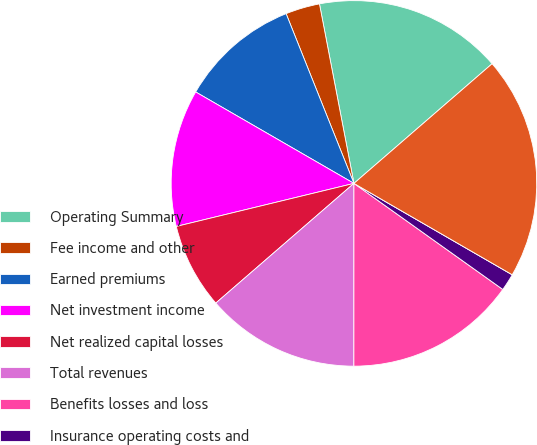Convert chart. <chart><loc_0><loc_0><loc_500><loc_500><pie_chart><fcel>Operating Summary<fcel>Fee income and other<fcel>Earned premiums<fcel>Net investment income<fcel>Net realized capital losses<fcel>Total revenues<fcel>Benefits losses and loss<fcel>Insurance operating costs and<fcel>Amortization of deferred<fcel>Total benefits losses and<nl><fcel>16.66%<fcel>3.03%<fcel>10.61%<fcel>12.12%<fcel>7.58%<fcel>13.63%<fcel>15.15%<fcel>1.52%<fcel>0.0%<fcel>19.69%<nl></chart> 